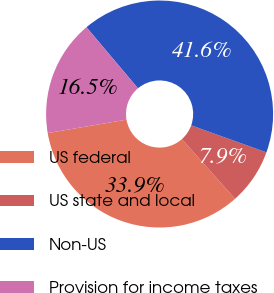Convert chart to OTSL. <chart><loc_0><loc_0><loc_500><loc_500><pie_chart><fcel>US federal<fcel>US state and local<fcel>Non-US<fcel>Provision for income taxes<nl><fcel>33.89%<fcel>7.94%<fcel>41.63%<fcel>16.54%<nl></chart> 